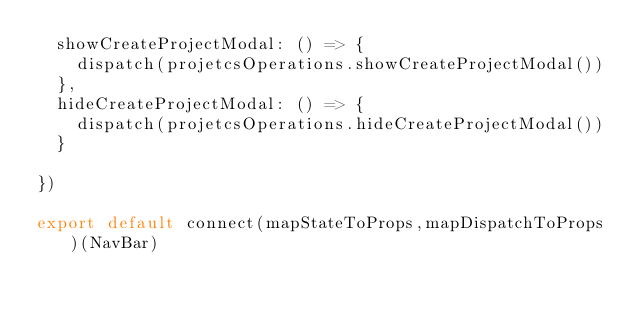<code> <loc_0><loc_0><loc_500><loc_500><_JavaScript_>  showCreateProjectModal: () => {
    dispatch(projetcsOperations.showCreateProjectModal())
  },
  hideCreateProjectModal: () => {
    dispatch(projetcsOperations.hideCreateProjectModal())
  }

})

export default connect(mapStateToProps,mapDispatchToProps)(NavBar)
</code> 